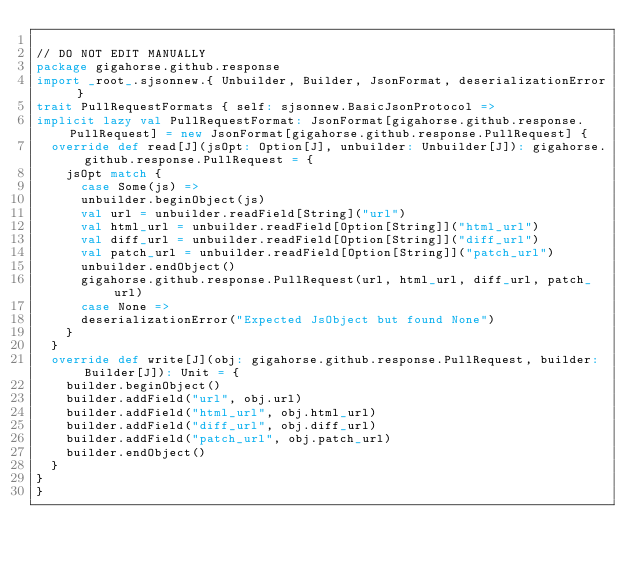<code> <loc_0><loc_0><loc_500><loc_500><_Scala_>
// DO NOT EDIT MANUALLY
package gigahorse.github.response
import _root_.sjsonnew.{ Unbuilder, Builder, JsonFormat, deserializationError }
trait PullRequestFormats { self: sjsonnew.BasicJsonProtocol =>
implicit lazy val PullRequestFormat: JsonFormat[gigahorse.github.response.PullRequest] = new JsonFormat[gigahorse.github.response.PullRequest] {
  override def read[J](jsOpt: Option[J], unbuilder: Unbuilder[J]): gigahorse.github.response.PullRequest = {
    jsOpt match {
      case Some(js) =>
      unbuilder.beginObject(js)
      val url = unbuilder.readField[String]("url")
      val html_url = unbuilder.readField[Option[String]]("html_url")
      val diff_url = unbuilder.readField[Option[String]]("diff_url")
      val patch_url = unbuilder.readField[Option[String]]("patch_url")
      unbuilder.endObject()
      gigahorse.github.response.PullRequest(url, html_url, diff_url, patch_url)
      case None =>
      deserializationError("Expected JsObject but found None")
    }
  }
  override def write[J](obj: gigahorse.github.response.PullRequest, builder: Builder[J]): Unit = {
    builder.beginObject()
    builder.addField("url", obj.url)
    builder.addField("html_url", obj.html_url)
    builder.addField("diff_url", obj.diff_url)
    builder.addField("patch_url", obj.patch_url)
    builder.endObject()
  }
}
}
</code> 